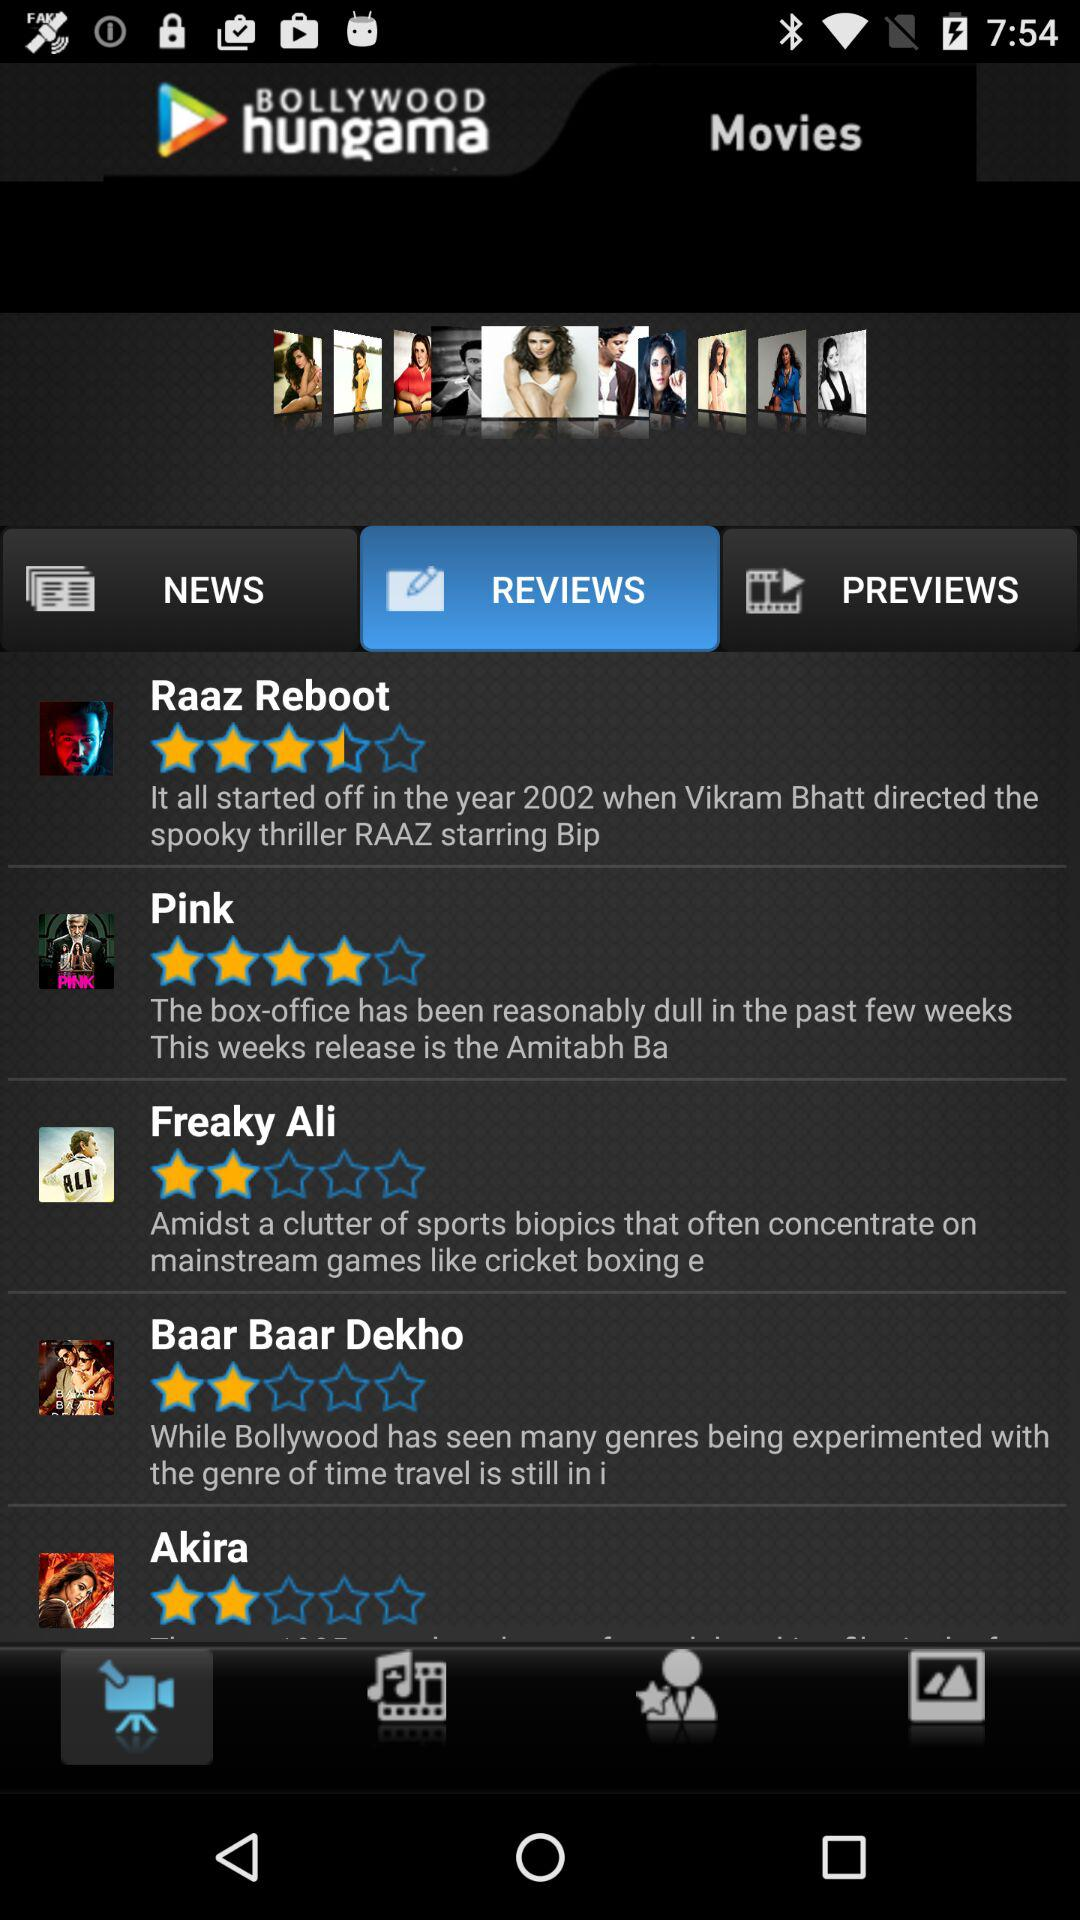Which tab is selected? The selected tabs are "Movies" and "REVIEWS". 